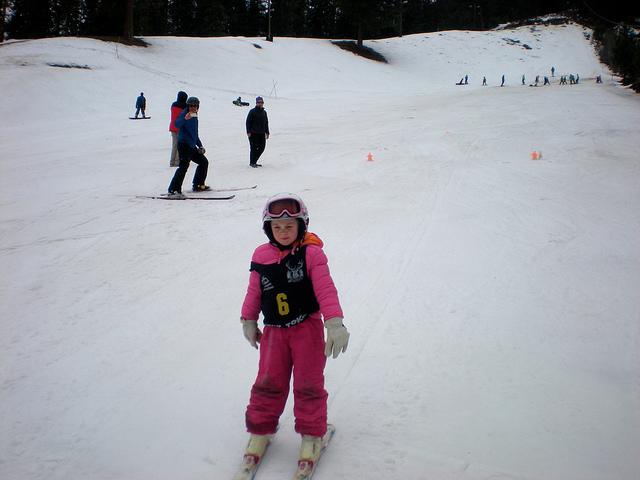What color is of the jacket?
Answer briefly. Pink. Is this child good at skating?
Short answer required. Yes. What activity is this?
Be succinct. Skiing. Is the ground entirely covered with snow?
Give a very brief answer. Yes. What age is the small person?
Quick response, please. 6. Is the skier smiling?
Quick response, please. No. Can her face be clearly seen?
Keep it brief. Yes. What color of cloth is the girl wearing?
Answer briefly. Pink. What are the people doing?
Be succinct. Skiing. Is this child posing for the photo?
Concise answer only. Yes. What is she standing on?
Keep it brief. Skis. 